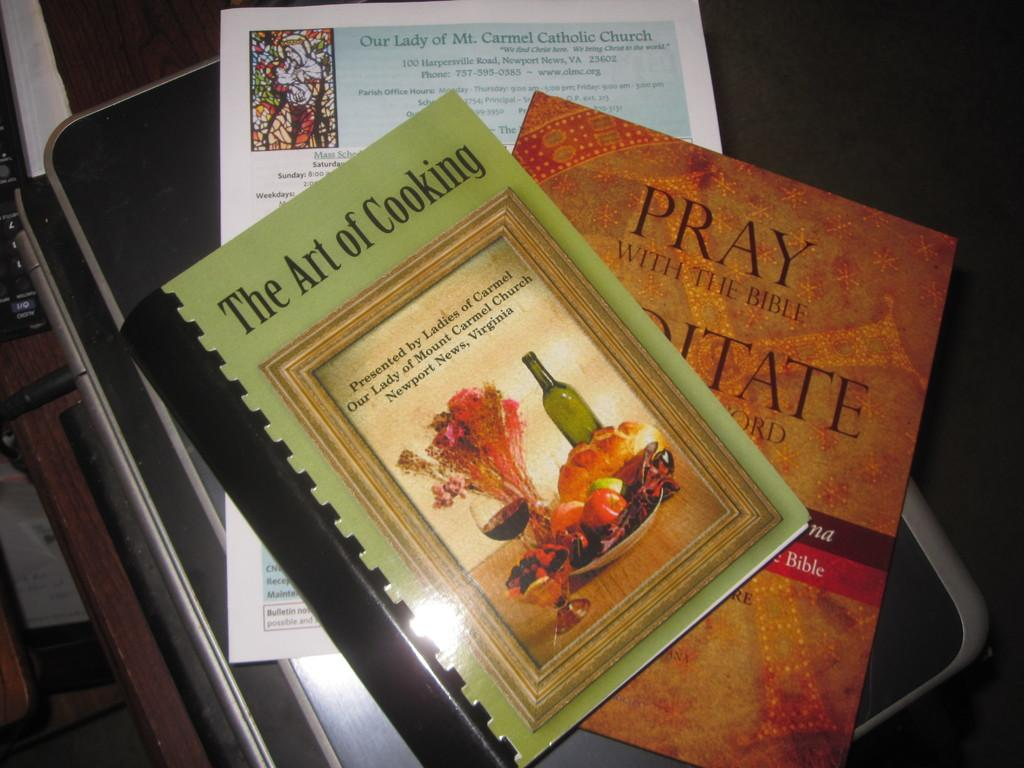<image>
Relay a brief, clear account of the picture shown. the art of cooking book which is next to others 